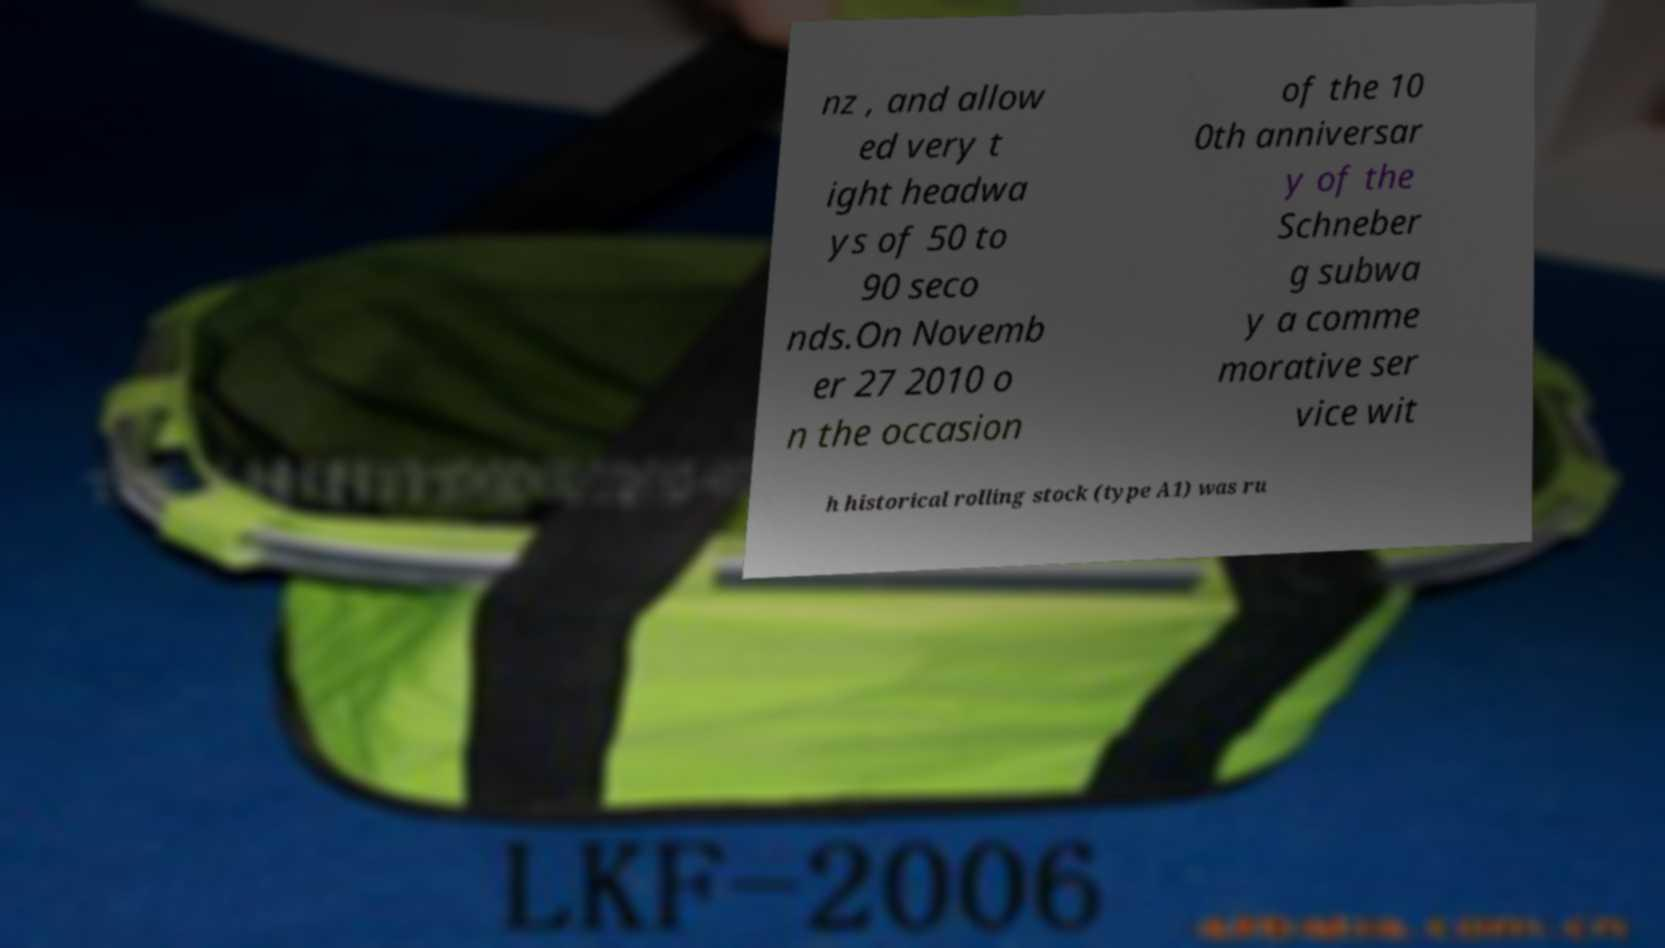I need the written content from this picture converted into text. Can you do that? nz , and allow ed very t ight headwa ys of 50 to 90 seco nds.On Novemb er 27 2010 o n the occasion of the 10 0th anniversar y of the Schneber g subwa y a comme morative ser vice wit h historical rolling stock (type A1) was ru 